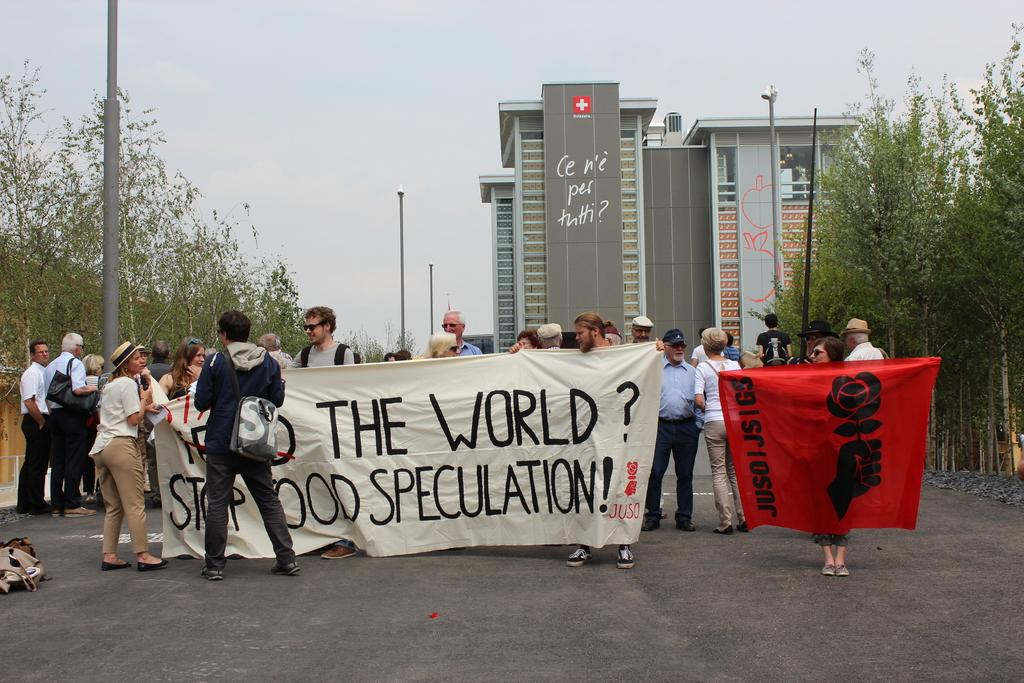Who or what can be seen in the image? There are people in the image. What structures are present in the image? There are poles and a building in the image. What type of vegetation is visible in the image? There are trees in the image. What additional items can be seen in the image? There are banners with text and images, objects on the ground, and the sky is visible in the image. What is the ground surface like in the image? There is ground visible in the image, and objects are present on it. Can you tell me how many teeth are visible on the banners in the image? There are no teeth present on the banners in the image; they contain text and images. What type of emotion is the building expressing in the image? Buildings do not express emotions; they are inanimate objects. 